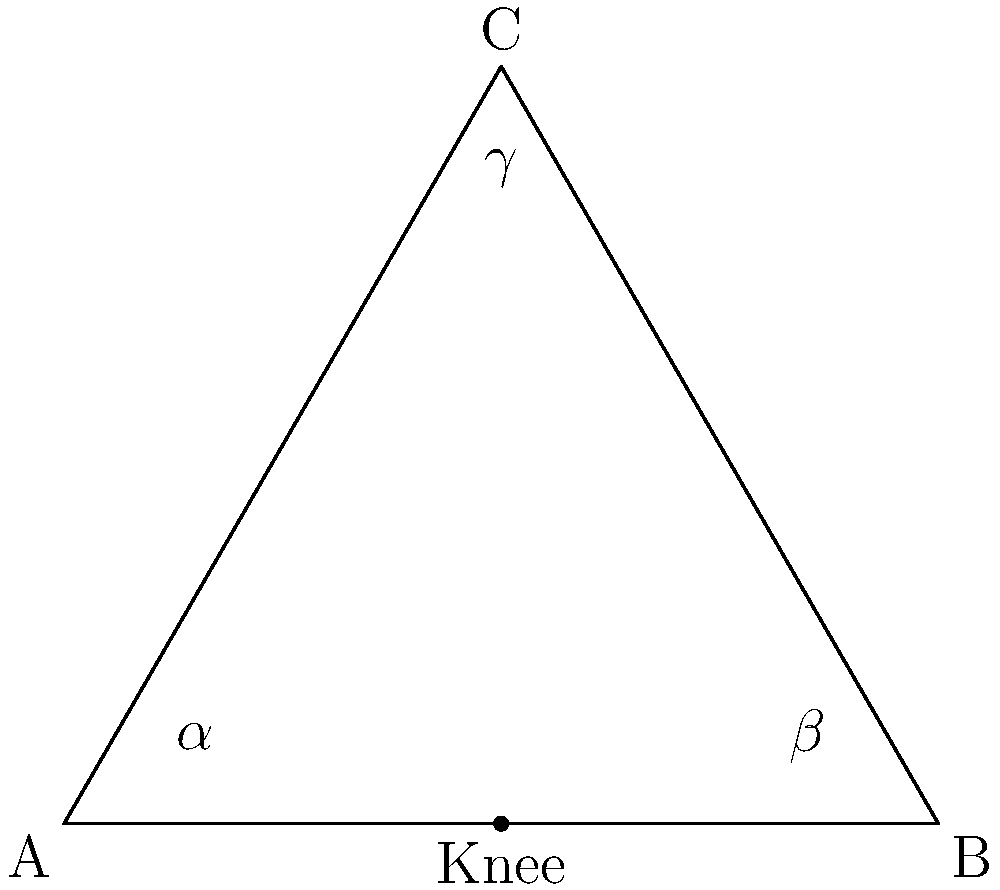In Wiz Khalifa's signature squat dance move, the angle between his thigh and lower leg forms an isosceles triangle. If the knee angle ($\gamma$) is 60°, what are the angles $\alpha$ and $\beta$ at the hip and ankle, respectively? To solve this problem, let's follow these steps:

1. Recognize that in an isosceles triangle, two angles are equal. In this case, $\alpha = \beta$.

2. Recall that the sum of angles in a triangle is always 180°:
   $$\alpha + \beta + \gamma = 180°$$

3. Given that $\gamma = 60°$, substitute this into the equation:
   $$\alpha + \beta + 60° = 180°$$

4. Since $\alpha = \beta$, we can rewrite the equation as:
   $$2\alpha + 60° = 180°$$

5. Solve for $\alpha$:
   $$2\alpha = 120°$$
   $$\alpha = 60°$$

6. Since $\alpha = \beta$, we know that $\beta$ is also 60°.

Therefore, in Wiz Khalifa's signature squat dance move, the angles at the hip ($\alpha$) and ankle ($\beta$) are both 60°, forming an equilateral triangle with the knee angle.
Answer: $\alpha = \beta = 60°$ 